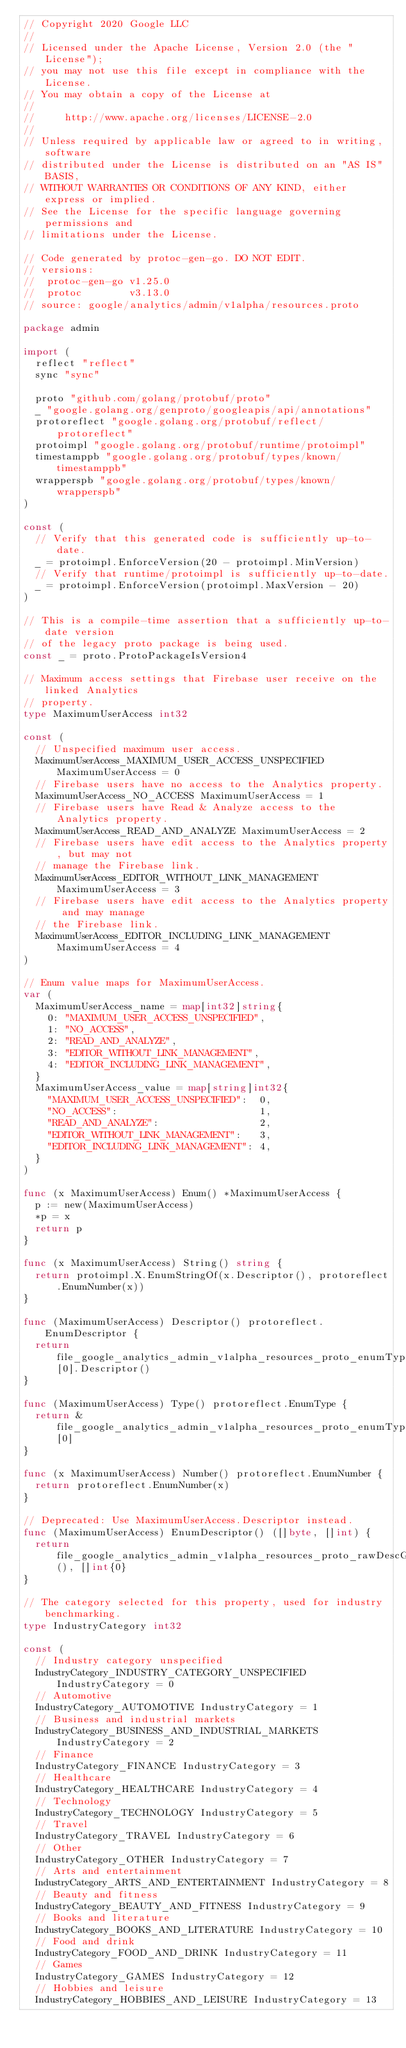<code> <loc_0><loc_0><loc_500><loc_500><_Go_>// Copyright 2020 Google LLC
//
// Licensed under the Apache License, Version 2.0 (the "License");
// you may not use this file except in compliance with the License.
// You may obtain a copy of the License at
//
//     http://www.apache.org/licenses/LICENSE-2.0
//
// Unless required by applicable law or agreed to in writing, software
// distributed under the License is distributed on an "AS IS" BASIS,
// WITHOUT WARRANTIES OR CONDITIONS OF ANY KIND, either express or implied.
// See the License for the specific language governing permissions and
// limitations under the License.

// Code generated by protoc-gen-go. DO NOT EDIT.
// versions:
// 	protoc-gen-go v1.25.0
// 	protoc        v3.13.0
// source: google/analytics/admin/v1alpha/resources.proto

package admin

import (
	reflect "reflect"
	sync "sync"

	proto "github.com/golang/protobuf/proto"
	_ "google.golang.org/genproto/googleapis/api/annotations"
	protoreflect "google.golang.org/protobuf/reflect/protoreflect"
	protoimpl "google.golang.org/protobuf/runtime/protoimpl"
	timestamppb "google.golang.org/protobuf/types/known/timestamppb"
	wrapperspb "google.golang.org/protobuf/types/known/wrapperspb"
)

const (
	// Verify that this generated code is sufficiently up-to-date.
	_ = protoimpl.EnforceVersion(20 - protoimpl.MinVersion)
	// Verify that runtime/protoimpl is sufficiently up-to-date.
	_ = protoimpl.EnforceVersion(protoimpl.MaxVersion - 20)
)

// This is a compile-time assertion that a sufficiently up-to-date version
// of the legacy proto package is being used.
const _ = proto.ProtoPackageIsVersion4

// Maximum access settings that Firebase user receive on the linked Analytics
// property.
type MaximumUserAccess int32

const (
	// Unspecified maximum user access.
	MaximumUserAccess_MAXIMUM_USER_ACCESS_UNSPECIFIED MaximumUserAccess = 0
	// Firebase users have no access to the Analytics property.
	MaximumUserAccess_NO_ACCESS MaximumUserAccess = 1
	// Firebase users have Read & Analyze access to the Analytics property.
	MaximumUserAccess_READ_AND_ANALYZE MaximumUserAccess = 2
	// Firebase users have edit access to the Analytics property, but may not
	// manage the Firebase link.
	MaximumUserAccess_EDITOR_WITHOUT_LINK_MANAGEMENT MaximumUserAccess = 3
	// Firebase users have edit access to the Analytics property and may manage
	// the Firebase link.
	MaximumUserAccess_EDITOR_INCLUDING_LINK_MANAGEMENT MaximumUserAccess = 4
)

// Enum value maps for MaximumUserAccess.
var (
	MaximumUserAccess_name = map[int32]string{
		0: "MAXIMUM_USER_ACCESS_UNSPECIFIED",
		1: "NO_ACCESS",
		2: "READ_AND_ANALYZE",
		3: "EDITOR_WITHOUT_LINK_MANAGEMENT",
		4: "EDITOR_INCLUDING_LINK_MANAGEMENT",
	}
	MaximumUserAccess_value = map[string]int32{
		"MAXIMUM_USER_ACCESS_UNSPECIFIED":  0,
		"NO_ACCESS":                        1,
		"READ_AND_ANALYZE":                 2,
		"EDITOR_WITHOUT_LINK_MANAGEMENT":   3,
		"EDITOR_INCLUDING_LINK_MANAGEMENT": 4,
	}
)

func (x MaximumUserAccess) Enum() *MaximumUserAccess {
	p := new(MaximumUserAccess)
	*p = x
	return p
}

func (x MaximumUserAccess) String() string {
	return protoimpl.X.EnumStringOf(x.Descriptor(), protoreflect.EnumNumber(x))
}

func (MaximumUserAccess) Descriptor() protoreflect.EnumDescriptor {
	return file_google_analytics_admin_v1alpha_resources_proto_enumTypes[0].Descriptor()
}

func (MaximumUserAccess) Type() protoreflect.EnumType {
	return &file_google_analytics_admin_v1alpha_resources_proto_enumTypes[0]
}

func (x MaximumUserAccess) Number() protoreflect.EnumNumber {
	return protoreflect.EnumNumber(x)
}

// Deprecated: Use MaximumUserAccess.Descriptor instead.
func (MaximumUserAccess) EnumDescriptor() ([]byte, []int) {
	return file_google_analytics_admin_v1alpha_resources_proto_rawDescGZIP(), []int{0}
}

// The category selected for this property, used for industry benchmarking.
type IndustryCategory int32

const (
	// Industry category unspecified
	IndustryCategory_INDUSTRY_CATEGORY_UNSPECIFIED IndustryCategory = 0
	// Automotive
	IndustryCategory_AUTOMOTIVE IndustryCategory = 1
	// Business and industrial markets
	IndustryCategory_BUSINESS_AND_INDUSTRIAL_MARKETS IndustryCategory = 2
	// Finance
	IndustryCategory_FINANCE IndustryCategory = 3
	// Healthcare
	IndustryCategory_HEALTHCARE IndustryCategory = 4
	// Technology
	IndustryCategory_TECHNOLOGY IndustryCategory = 5
	// Travel
	IndustryCategory_TRAVEL IndustryCategory = 6
	// Other
	IndustryCategory_OTHER IndustryCategory = 7
	// Arts and entertainment
	IndustryCategory_ARTS_AND_ENTERTAINMENT IndustryCategory = 8
	// Beauty and fitness
	IndustryCategory_BEAUTY_AND_FITNESS IndustryCategory = 9
	// Books and literature
	IndustryCategory_BOOKS_AND_LITERATURE IndustryCategory = 10
	// Food and drink
	IndustryCategory_FOOD_AND_DRINK IndustryCategory = 11
	// Games
	IndustryCategory_GAMES IndustryCategory = 12
	// Hobbies and leisure
	IndustryCategory_HOBBIES_AND_LEISURE IndustryCategory = 13</code> 